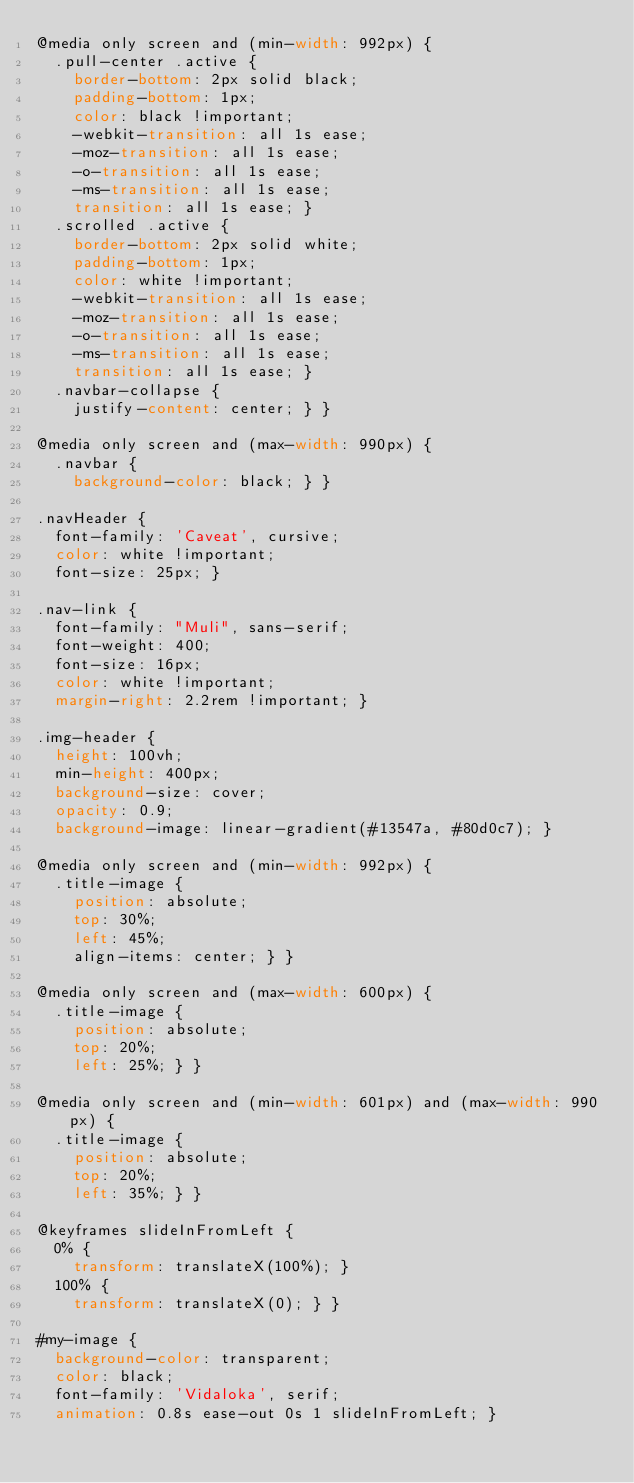<code> <loc_0><loc_0><loc_500><loc_500><_CSS_>@media only screen and (min-width: 992px) {
  .pull-center .active {
    border-bottom: 2px solid black;
    padding-bottom: 1px;
    color: black !important;
    -webkit-transition: all 1s ease;
    -moz-transition: all 1s ease;
    -o-transition: all 1s ease;
    -ms-transition: all 1s ease;
    transition: all 1s ease; }
  .scrolled .active {
    border-bottom: 2px solid white;
    padding-bottom: 1px;
    color: white !important;
    -webkit-transition: all 1s ease;
    -moz-transition: all 1s ease;
    -o-transition: all 1s ease;
    -ms-transition: all 1s ease;
    transition: all 1s ease; }
  .navbar-collapse {
    justify-content: center; } }

@media only screen and (max-width: 990px) {
  .navbar {
    background-color: black; } }

.navHeader {
  font-family: 'Caveat', cursive;
  color: white !important;
  font-size: 25px; }

.nav-link {
  font-family: "Muli", sans-serif;
  font-weight: 400;
  font-size: 16px;
  color: white !important;
  margin-right: 2.2rem !important; }

.img-header {
  height: 100vh;
  min-height: 400px;
  background-size: cover;
  opacity: 0.9;
  background-image: linear-gradient(#13547a, #80d0c7); }

@media only screen and (min-width: 992px) {
  .title-image {
    position: absolute;
    top: 30%;
    left: 45%;
    align-items: center; } }

@media only screen and (max-width: 600px) {
  .title-image {
    position: absolute;
    top: 20%;
    left: 25%; } }

@media only screen and (min-width: 601px) and (max-width: 990px) {
  .title-image {
    position: absolute;
    top: 20%;
    left: 35%; } }

@keyframes slideInFromLeft {
  0% {
    transform: translateX(100%); }
  100% {
    transform: translateX(0); } }

#my-image {
  background-color: transparent;
  color: black;
  font-family: 'Vidaloka', serif;
  animation: 0.8s ease-out 0s 1 slideInFromLeft; }</code> 